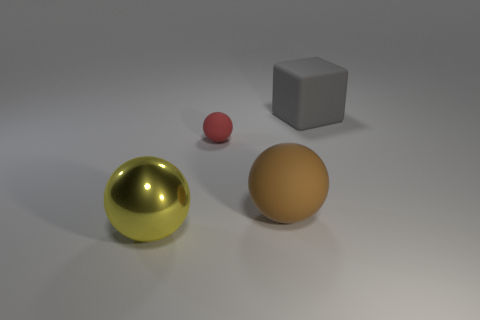What color is the big ball that is behind the thing in front of the matte object that is in front of the tiny red ball?
Provide a short and direct response. Brown. Are the yellow thing and the small sphere made of the same material?
Offer a terse response. No. There is a large thing on the left side of the big rubber object left of the big gray matte object; are there any big brown matte objects to the left of it?
Your answer should be compact. No. Does the tiny rubber thing have the same color as the large matte ball?
Provide a succinct answer. No. Is the number of big blue objects less than the number of yellow objects?
Your answer should be compact. Yes. Are the big ball in front of the big brown matte sphere and the sphere behind the big brown ball made of the same material?
Your answer should be compact. No. Is the number of brown things behind the brown sphere less than the number of yellow metallic balls?
Your answer should be very brief. Yes. There is a matte object on the right side of the large brown matte thing; what number of small things are in front of it?
Your answer should be compact. 1. There is a matte thing that is both right of the tiny red matte object and in front of the big rubber cube; how big is it?
Keep it short and to the point. Large. Is there any other thing that has the same material as the gray object?
Ensure brevity in your answer.  Yes. 